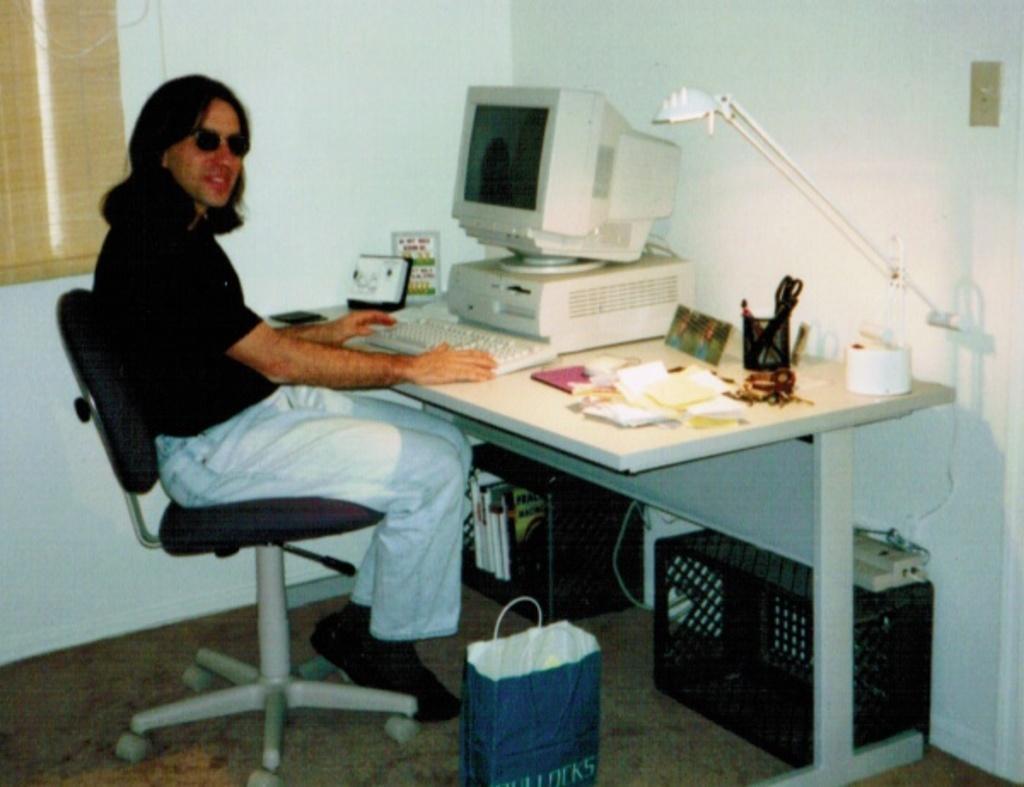Please provide a concise description of this image. As we can see in the image there is a white color wall, a man sitting on chair, cover and a table. On table there are papers, tissues, light, keyboard and screen. 